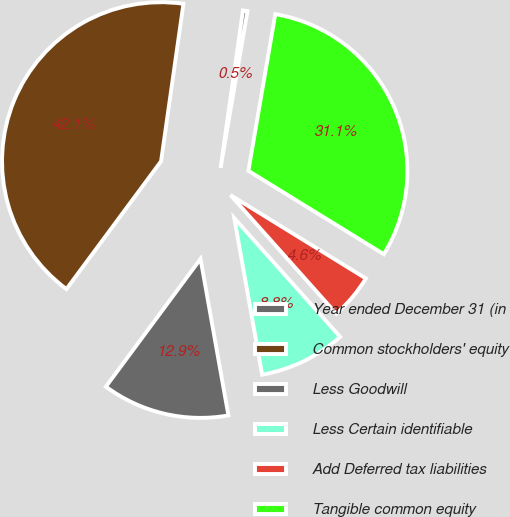<chart> <loc_0><loc_0><loc_500><loc_500><pie_chart><fcel>Year ended December 31 (in<fcel>Common stockholders' equity<fcel>Less Goodwill<fcel>Less Certain identifiable<fcel>Add Deferred tax liabilities<fcel>Tangible common equity<nl><fcel>0.46%<fcel>42.1%<fcel>12.95%<fcel>8.79%<fcel>4.62%<fcel>31.08%<nl></chart> 